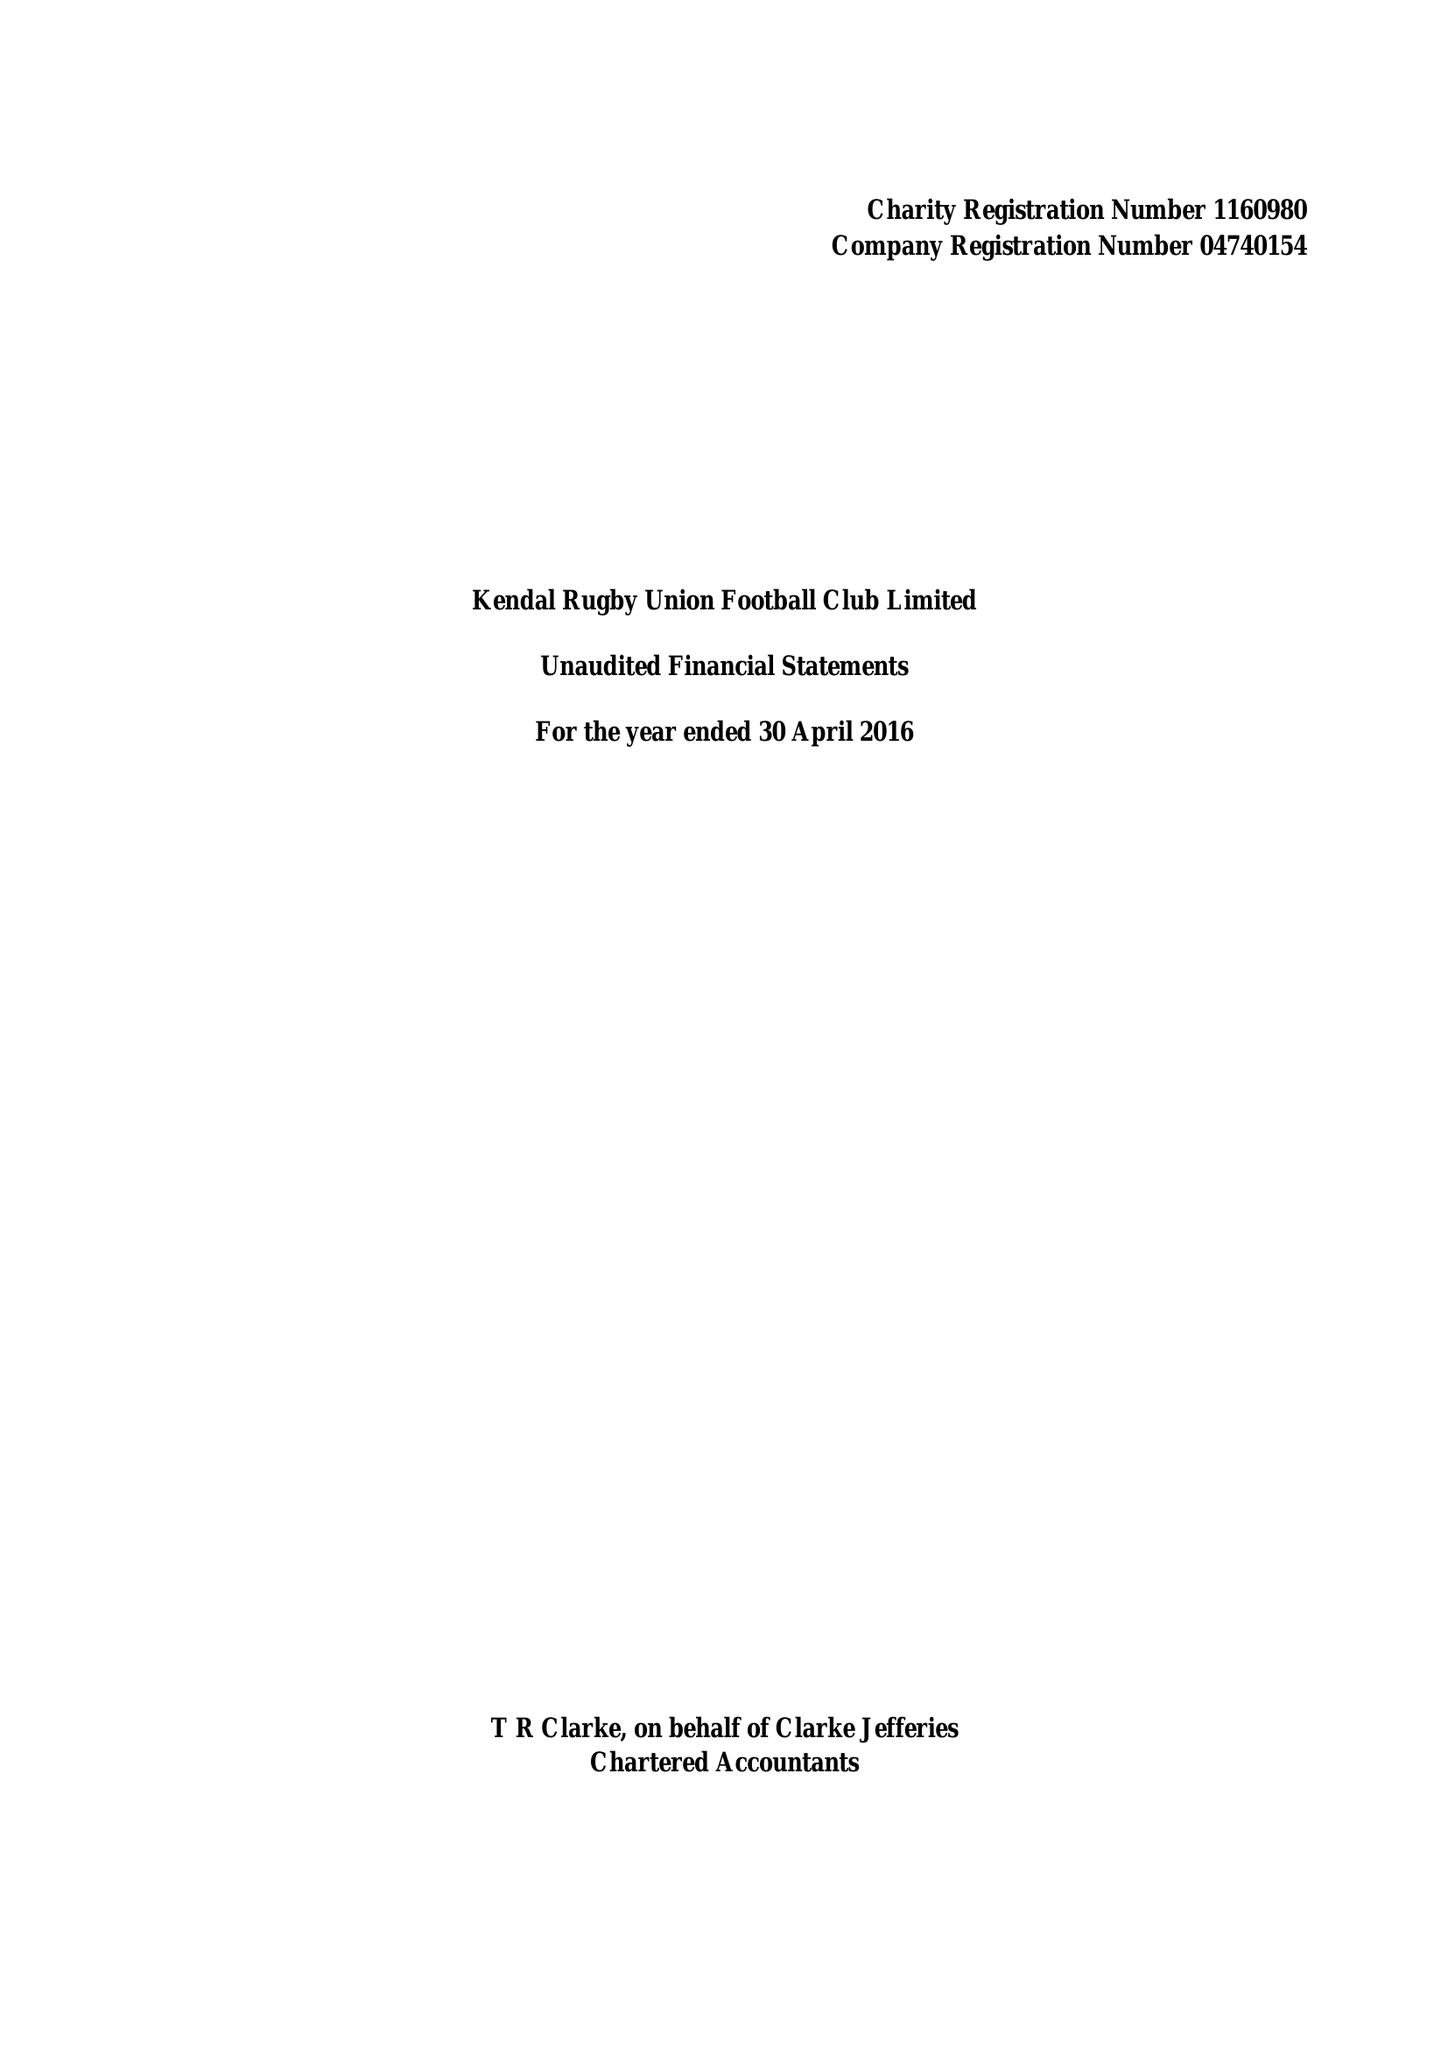What is the value for the report_date?
Answer the question using a single word or phrase. 2016-04-30 